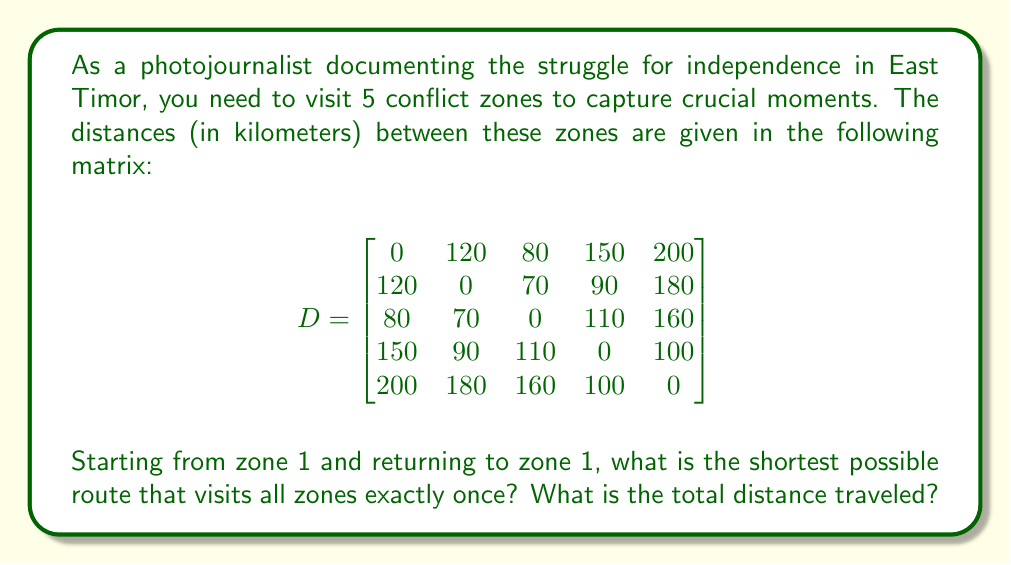Help me with this question. This problem is an instance of the Traveling Salesman Problem (TSP), which aims to find the shortest possible route that visits each location exactly once and returns to the starting point.

For 5 zones, there are $(5-1)!/2 = 12$ possible routes to consider (we divide by 2 because the problem is symmetric, i.e., traveling clockwise or counterclockwise results in the same distance).

Let's enumerate all possible routes and calculate their total distances:

1. 1-2-3-4-5-1: $120 + 70 + 110 + 100 + 200 = 600$ km
2. 1-2-3-5-4-1: $120 + 70 + 160 + 100 + 150 = 600$ km
3. 1-2-4-3-5-1: $120 + 90 + 110 + 160 + 200 = 680$ km
4. 1-2-4-5-3-1: $120 + 90 + 100 + 160 + 80 = 550$ km
5. 1-2-5-3-4-1: $120 + 180 + 160 + 110 + 150 = 720$ km
6. 1-2-5-4-3-1: $120 + 180 + 100 + 110 + 80 = 590$ km
7. 1-3-2-4-5-1: $80 + 70 + 90 + 100 + 200 = 540$ km
8. 1-3-2-5-4-1: $80 + 70 + 180 + 100 + 150 = 580$ km
9. 1-3-4-2-5-1: $80 + 110 + 90 + 180 + 200 = 660$ km
10. 1-3-4-5-2-1: $80 + 110 + 100 + 180 + 120 = 590$ km
11. 1-3-5-2-4-1: $80 + 160 + 180 + 90 + 150 = 660$ km
12. 1-3-5-4-2-1: $80 + 160 + 100 + 90 + 120 = 550$ km

The shortest route is 1-3-2-4-5-1 with a total distance of 540 km.
Answer: The shortest route is 1-3-2-4-5-1, and the total distance traveled is 540 km. 